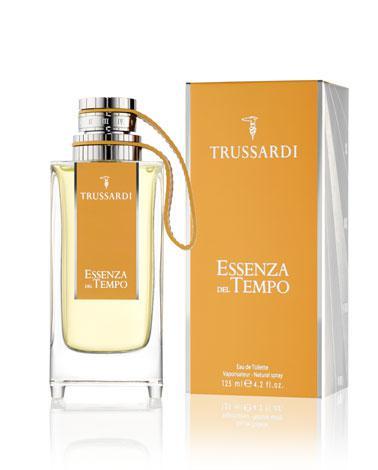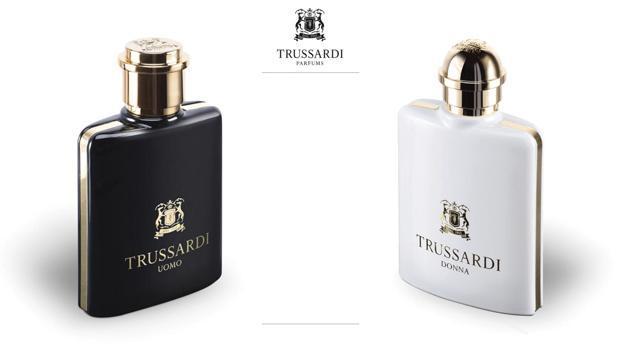The first image is the image on the left, the second image is the image on the right. Analyze the images presented: Is the assertion "There is a rectangular cap to a vial in one of the images." valid? Answer yes or no. No. The first image is the image on the left, the second image is the image on the right. For the images shown, is this caption "Each image includes exactly two objects, and one image features an upright angled black bottle to the left of an upright angled white bottle." true? Answer yes or no. Yes. 